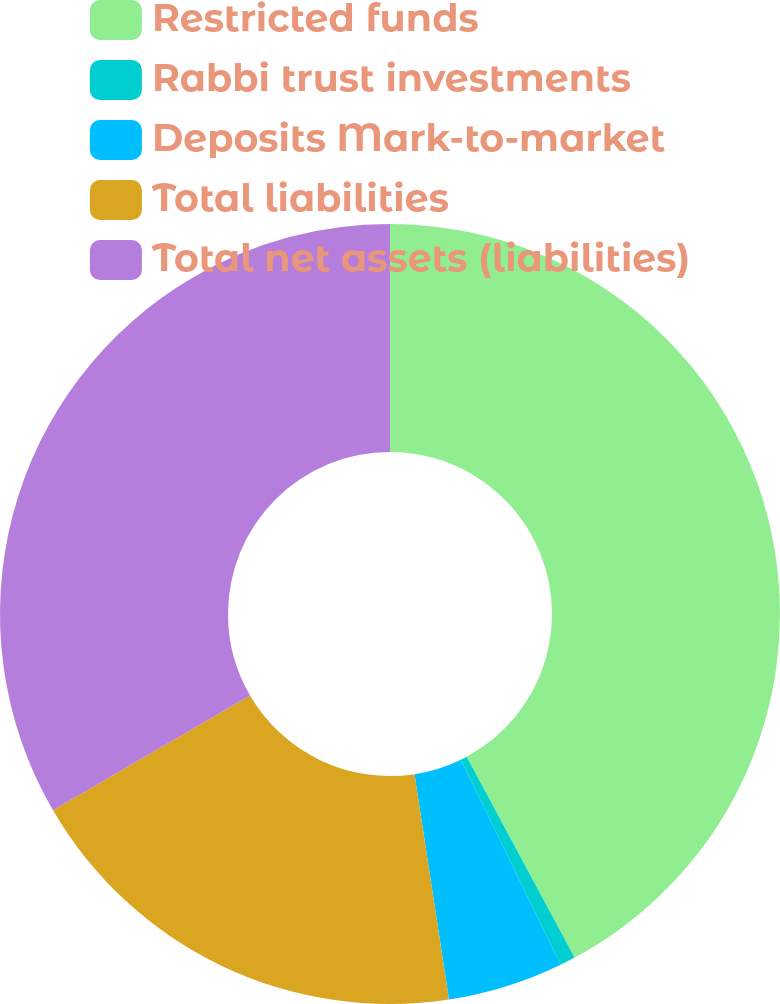Convert chart to OTSL. <chart><loc_0><loc_0><loc_500><loc_500><pie_chart><fcel>Restricted funds<fcel>Rabbi trust investments<fcel>Deposits Mark-to-market<fcel>Total liabilities<fcel>Total net assets (liabilities)<nl><fcel>42.15%<fcel>0.64%<fcel>4.79%<fcel>19.02%<fcel>33.39%<nl></chart> 